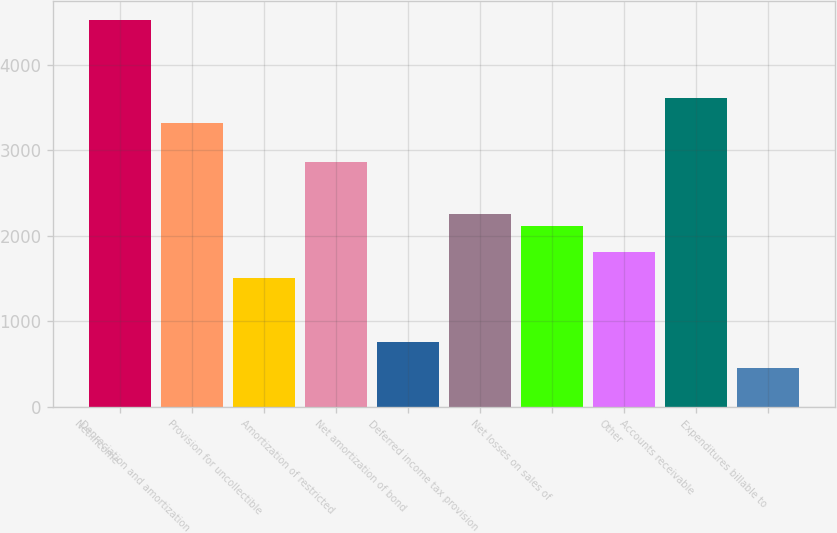Convert chart. <chart><loc_0><loc_0><loc_500><loc_500><bar_chart><fcel>Net income<fcel>Depreciation and amortization<fcel>Provision for uncollectible<fcel>Amortization of restricted<fcel>Net amortization of bond<fcel>Deferred income tax provision<fcel>Net losses on sales of<fcel>Other<fcel>Accounts receivable<fcel>Expenditures billable to<nl><fcel>4516.9<fcel>3312.58<fcel>1506.1<fcel>2860.96<fcel>753.4<fcel>2258.8<fcel>2108.26<fcel>1807.18<fcel>3613.66<fcel>452.32<nl></chart> 